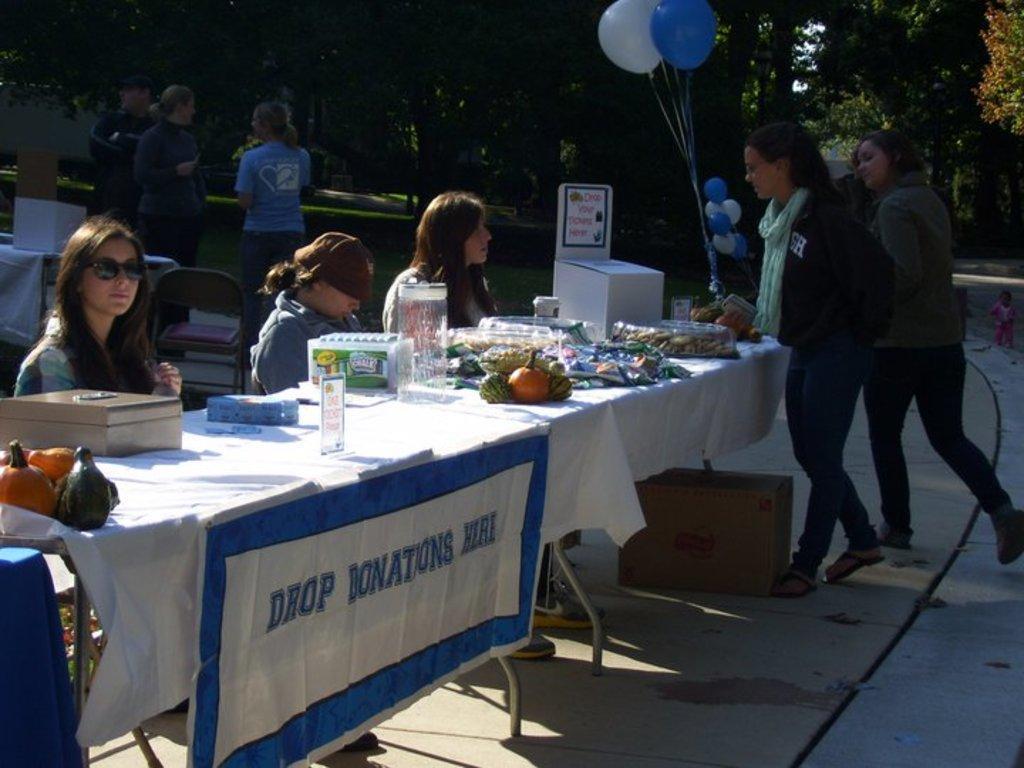Can you describe this image briefly? Three women are sitting at a donation table while two women approached them. 